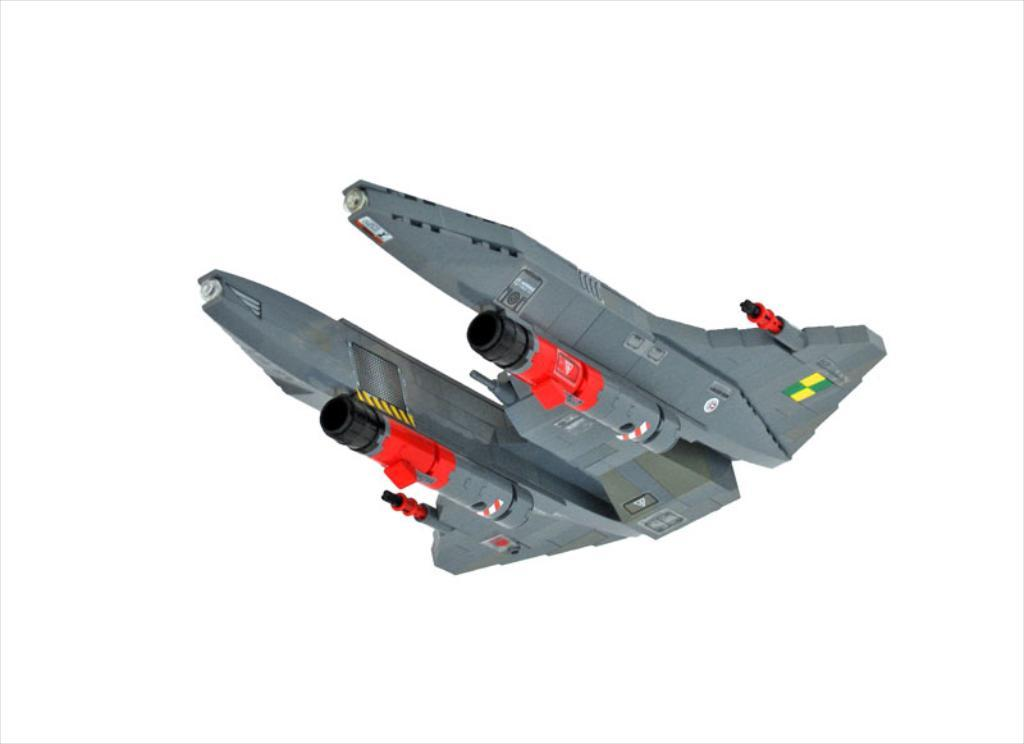What is the main subject of the image? The main subject of the image is a jet plane. What can be observed about the background of the image? The background of the image is white in color. What type of activity is the company engaging in with the jet plane in the image? There is no company or activity mentioned or depicted in the image; it only features a jet plane against a white background. Can you see any rub marks on the jet plane in the image? There is no indication of rub marks or any other damage on the jet plane in the image. 